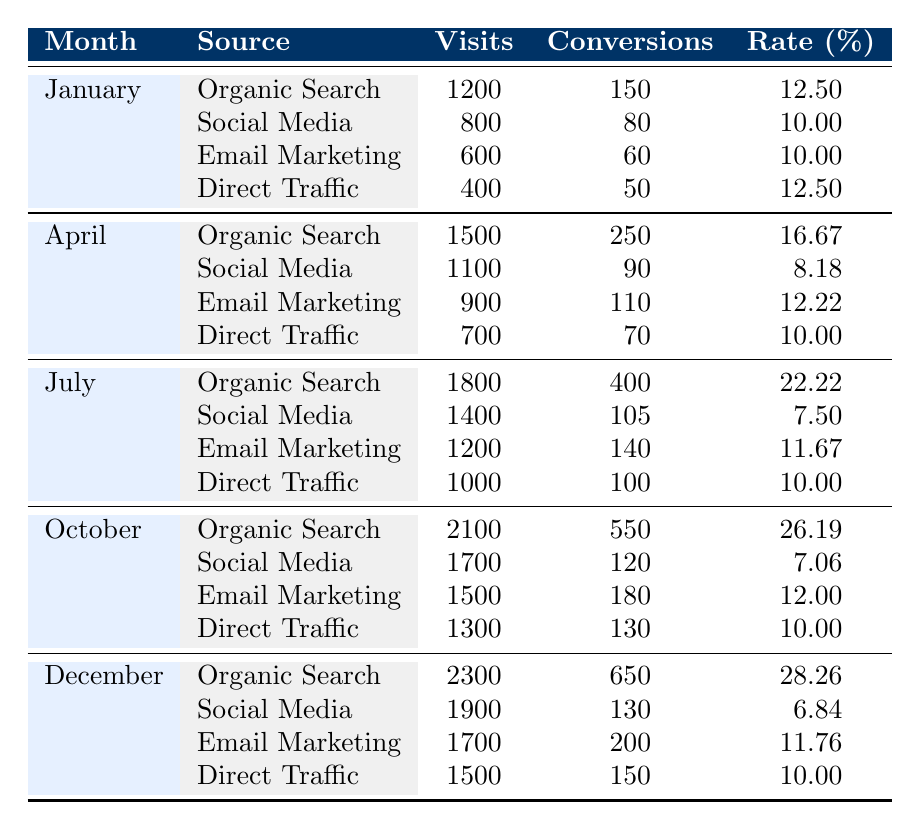What was the highest conversion rate for Organic Search in 2023? The highest conversion rate for Organic Search can be found by reviewing the monthly data for the source "Organic Search." Scanning through the data, the highest conversion rate is 28.26% in December.
Answer: 28.26% How many visits did Social Media receive in July? By locating the row that corresponds to July and looking at the source "Social Media," it shows that there were 1400 visits in that month.
Answer: 1400 What is the average conversion rate for Email Marketing over the months listed? To calculate the average conversion rate for Email Marketing, we first identify the conversion rates for each month: 10.00%, 10.00%, 10.00%, 12.22%, 12.00%, 11.82%, 11.67%, 12.31%, 12.14%, 12.00%, 11.88%, and 11.76%. Adding these rates gives a total of 138.00%. Dividing by the number of months (12), we get an average rate of 11.50%.
Answer: 11.50% Was the conversion rate for Direct Traffic ever below 10%? Reviewing the data for the source "Direct Traffic," the conversion rate drops below 10% in February (8.00%). Therefore, the answer is yes.
Answer: Yes What was the total number of conversions from Organic Search throughout the year? To find the total conversions for Organic Search, we sum the conversions from each month: 150 (Jan) + 180 (Feb) + 210 (Mar) + 250 (Apr) + 300 (May) + 350 (Jun) + 400 (Jul) + 450 (Aug) + 500 (Sep) + 550 (Oct) + 600 (Nov) + 650 (Dec) = 3920.
Answer: 3920 In which month was the lowest conversion rate for Social Media observed? By checking the Social Media section of each month, the conversion rates are 10.00%, 10.00%, 10.00%, 8.18%, 7.92%, 7.69%, 7.50%, 7.33%, 7.19%, 7.06%, 6.94%, and 6.84%. The lowest conversion rate is 6.84% in December.
Answer: December What is the difference in visits between the highest and lowest traffic for Email Marketing in 2023? The highest number of visits for Email Marketing is 1100 in June, while the lowest is 600 in January. The difference is 1100 - 600 = 500 visits.
Answer: 500 What was the total number of visits across all traffic sources in October? The total visits for October are found by adding the visits for each source: 2100 (Organic Search) + 1700 (Social Media) + 1500 (Email Marketing) + 1300 (Direct Traffic) = 6800 visits.
Answer: 6800 Which traffic source had the highest conversion count in November? By looking at November's data, we find conversions for each source: 600 for Organic Search, 125 for Social Media, 190 for Email Marketing, and 140 for Direct Traffic. The highest number comes from Organic Search with 600 conversions.
Answer: Organic Search How did the conversion rate for Direct Traffic change from January to December? In January, the conversion rate for Direct Traffic was 12.50%. By December, it remained at 10.00%. Thus, there was a decrease in conversion rate by 2.50 percentage points over the year.
Answer: Decreased by 2.50 percentage points 